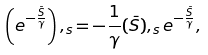<formula> <loc_0><loc_0><loc_500><loc_500>\left ( e ^ { - \frac { \bar { S } } { \gamma } } \right ) , _ { s } = - \frac { 1 } { \gamma } ( \bar { S } ) , _ { s } e ^ { - \frac { \bar { S } } { \gamma } } ,</formula> 